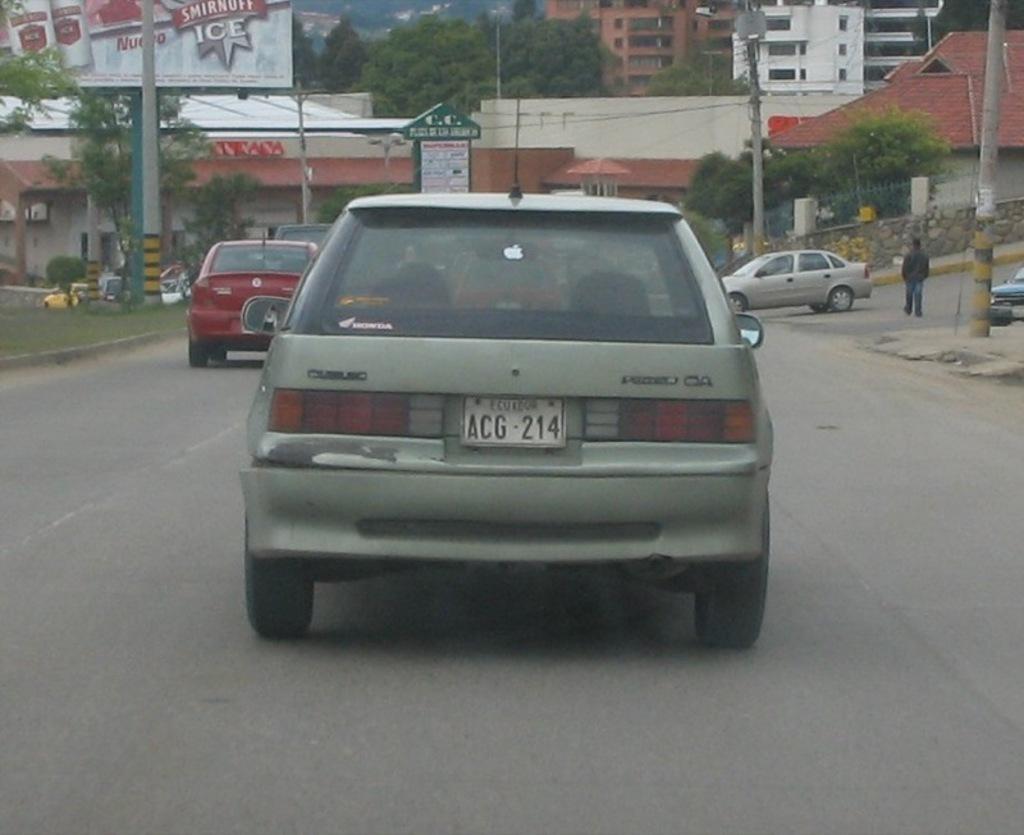How would you summarize this image in a sentence or two? In the picture we can see a road on it, we can see some cars and beside the road we can see a grass surface and on it we can see some pole with a hoarding and on the other side, we can see some part of the road and a vehicle on it and a man standing and beside it we can see some poles and building and in the background also we can see some buildings and trees. 